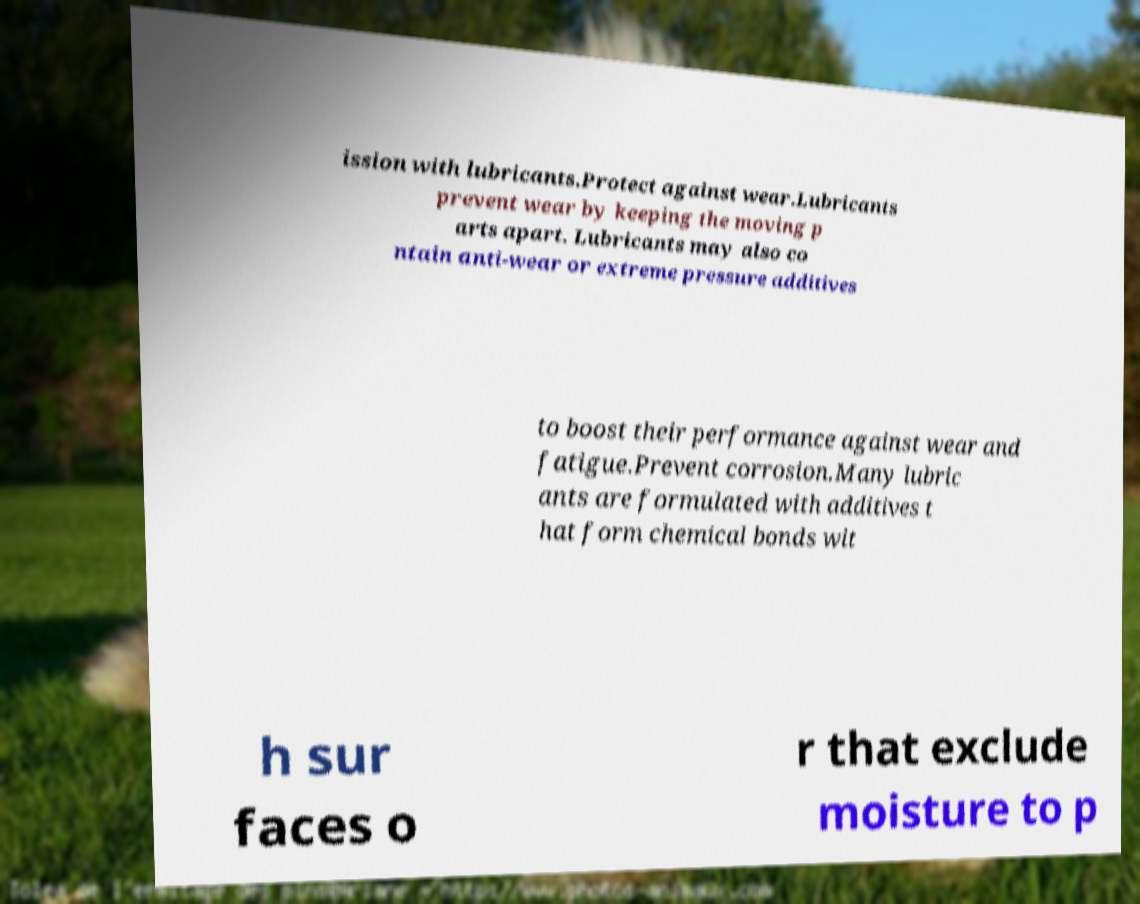What messages or text are displayed in this image? I need them in a readable, typed format. ission with lubricants.Protect against wear.Lubricants prevent wear by keeping the moving p arts apart. Lubricants may also co ntain anti-wear or extreme pressure additives to boost their performance against wear and fatigue.Prevent corrosion.Many lubric ants are formulated with additives t hat form chemical bonds wit h sur faces o r that exclude moisture to p 